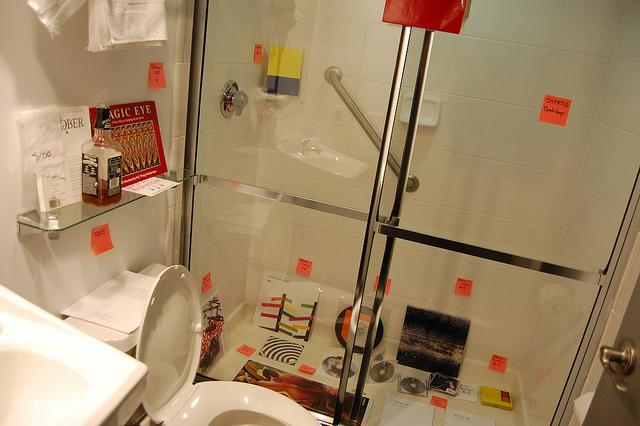What is near the bottle of alcohol?

Choices:
A) toilet
B) whistle
C) man
D) bunny toilet 